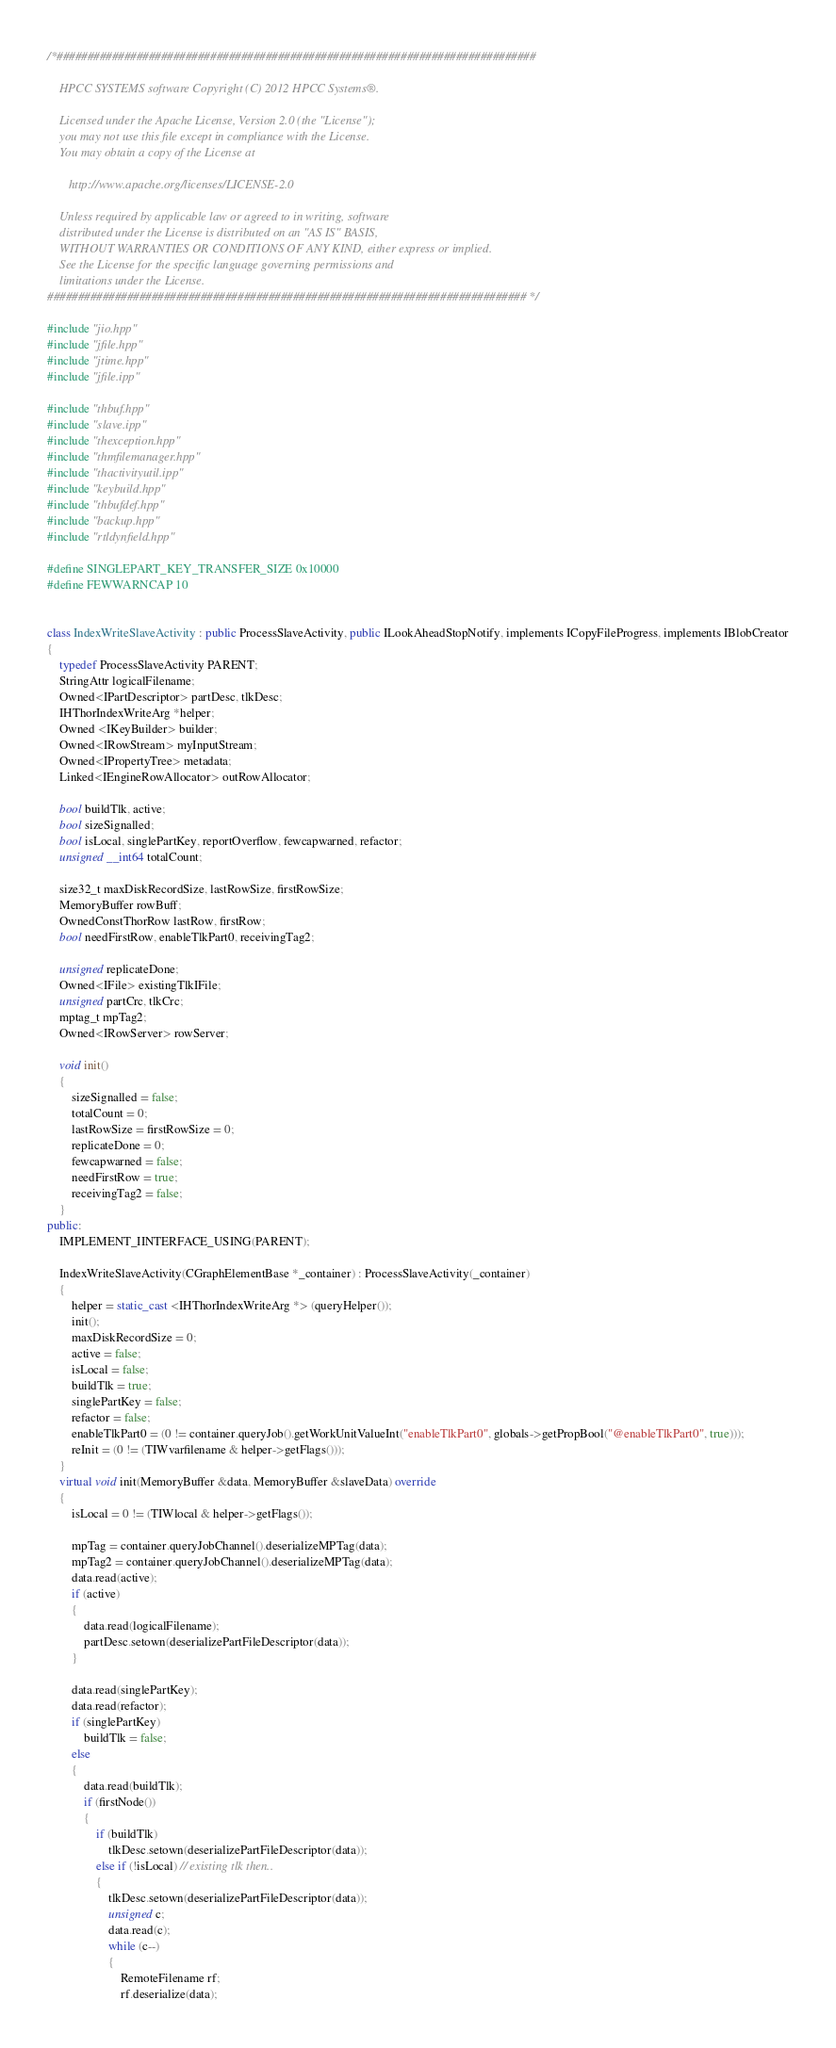<code> <loc_0><loc_0><loc_500><loc_500><_C++_>/*##############################################################################

    HPCC SYSTEMS software Copyright (C) 2012 HPCC Systems®.

    Licensed under the Apache License, Version 2.0 (the "License");
    you may not use this file except in compliance with the License.
    You may obtain a copy of the License at

       http://www.apache.org/licenses/LICENSE-2.0

    Unless required by applicable law or agreed to in writing, software
    distributed under the License is distributed on an "AS IS" BASIS,
    WITHOUT WARRANTIES OR CONDITIONS OF ANY KIND, either express or implied.
    See the License for the specific language governing permissions and
    limitations under the License.
############################################################################## */

#include "jio.hpp"
#include "jfile.hpp"
#include "jtime.hpp"
#include "jfile.ipp"

#include "thbuf.hpp"
#include "slave.ipp"
#include "thexception.hpp"
#include "thmfilemanager.hpp"
#include "thactivityutil.ipp"
#include "keybuild.hpp"
#include "thbufdef.hpp"
#include "backup.hpp"
#include "rtldynfield.hpp"

#define SINGLEPART_KEY_TRANSFER_SIZE 0x10000
#define FEWWARNCAP 10


class IndexWriteSlaveActivity : public ProcessSlaveActivity, public ILookAheadStopNotify, implements ICopyFileProgress, implements IBlobCreator
{
    typedef ProcessSlaveActivity PARENT;
    StringAttr logicalFilename;
    Owned<IPartDescriptor> partDesc, tlkDesc;
    IHThorIndexWriteArg *helper;
    Owned <IKeyBuilder> builder;
    Owned<IRowStream> myInputStream;
    Owned<IPropertyTree> metadata;
    Linked<IEngineRowAllocator> outRowAllocator;

    bool buildTlk, active;
    bool sizeSignalled;
    bool isLocal, singlePartKey, reportOverflow, fewcapwarned, refactor;
    unsigned __int64 totalCount;

    size32_t maxDiskRecordSize, lastRowSize, firstRowSize;
    MemoryBuffer rowBuff;
    OwnedConstThorRow lastRow, firstRow;
    bool needFirstRow, enableTlkPart0, receivingTag2;

    unsigned replicateDone;
    Owned<IFile> existingTlkIFile;
    unsigned partCrc, tlkCrc;
    mptag_t mpTag2;
    Owned<IRowServer> rowServer;

    void init()
    {
        sizeSignalled = false;
        totalCount = 0;
        lastRowSize = firstRowSize = 0;
        replicateDone = 0;
        fewcapwarned = false;
        needFirstRow = true;
        receivingTag2 = false;
    }
public:
    IMPLEMENT_IINTERFACE_USING(PARENT);

    IndexWriteSlaveActivity(CGraphElementBase *_container) : ProcessSlaveActivity(_container)
    {
        helper = static_cast <IHThorIndexWriteArg *> (queryHelper());
        init();
        maxDiskRecordSize = 0;
        active = false;
        isLocal = false;
        buildTlk = true;
        singlePartKey = false;
        refactor = false;
        enableTlkPart0 = (0 != container.queryJob().getWorkUnitValueInt("enableTlkPart0", globals->getPropBool("@enableTlkPart0", true)));
        reInit = (0 != (TIWvarfilename & helper->getFlags()));
    }
    virtual void init(MemoryBuffer &data, MemoryBuffer &slaveData) override
    {
        isLocal = 0 != (TIWlocal & helper->getFlags());

        mpTag = container.queryJobChannel().deserializeMPTag(data);
        mpTag2 = container.queryJobChannel().deserializeMPTag(data);
        data.read(active);
        if (active)
        {
            data.read(logicalFilename);
            partDesc.setown(deserializePartFileDescriptor(data));
        }

        data.read(singlePartKey);
        data.read(refactor);
        if (singlePartKey)
            buildTlk = false;
        else
        {
            data.read(buildTlk);
            if (firstNode())
            {
                if (buildTlk)
                    tlkDesc.setown(deserializePartFileDescriptor(data));
                else if (!isLocal) // existing tlk then..
                {
                    tlkDesc.setown(deserializePartFileDescriptor(data));
                    unsigned c;
                    data.read(c);
                    while (c--)
                    {
                        RemoteFilename rf;
                        rf.deserialize(data);</code> 